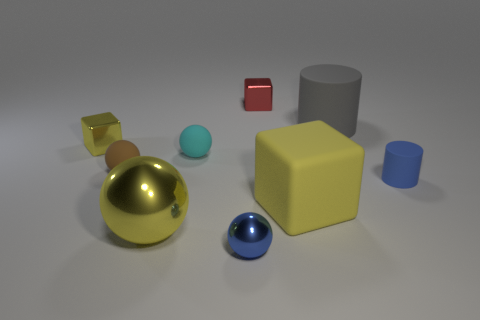Subtract all purple cylinders. How many yellow cubes are left? 2 Subtract all large spheres. How many spheres are left? 3 Subtract 1 balls. How many balls are left? 3 Add 1 yellow cubes. How many objects exist? 10 Subtract all cyan balls. How many balls are left? 3 Subtract all gray spheres. Subtract all blue cubes. How many spheres are left? 4 Add 9 blue metallic things. How many blue metallic things are left? 10 Add 8 big spheres. How many big spheres exist? 9 Subtract 1 yellow spheres. How many objects are left? 8 Subtract all cylinders. How many objects are left? 7 